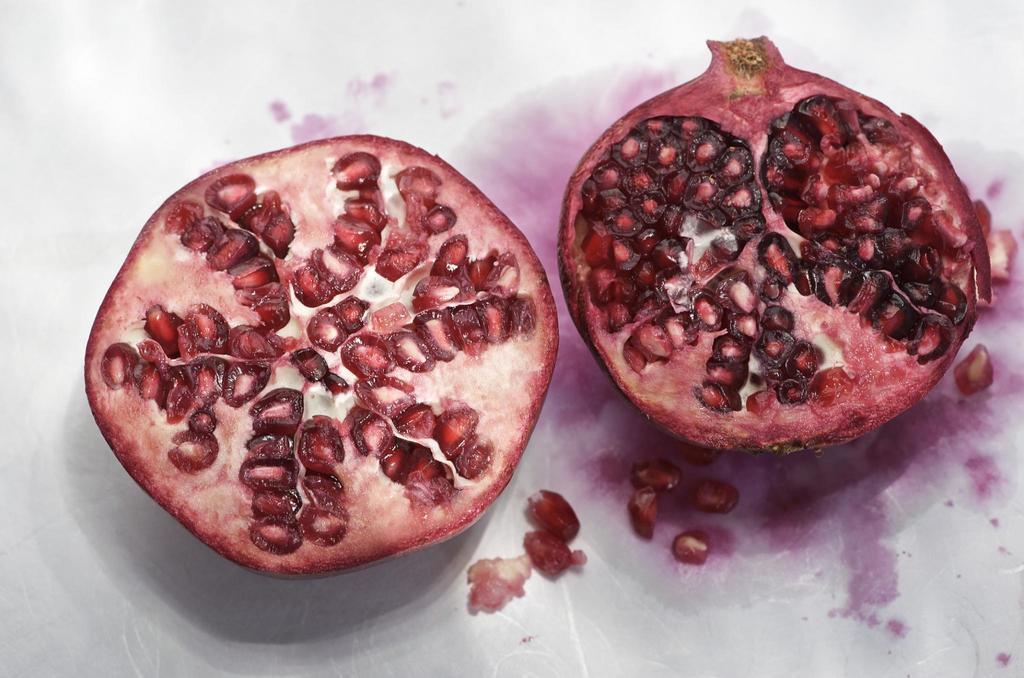Could you give a brief overview of what you see in this image? In this image there are two pieces of a pomegranate. 